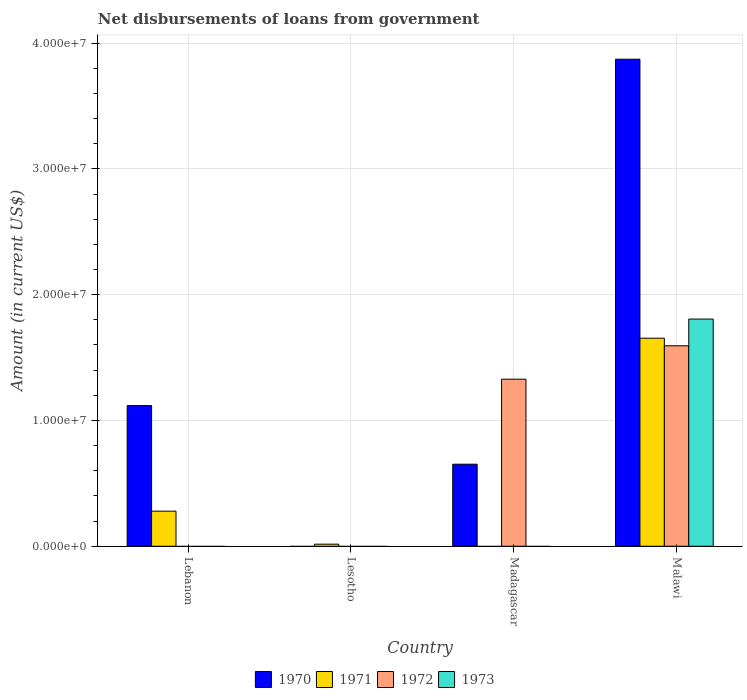How many different coloured bars are there?
Provide a succinct answer. 4. Are the number of bars per tick equal to the number of legend labels?
Keep it short and to the point. No. Are the number of bars on each tick of the X-axis equal?
Your answer should be very brief. No. How many bars are there on the 4th tick from the left?
Your answer should be very brief. 4. How many bars are there on the 2nd tick from the right?
Keep it short and to the point. 2. What is the label of the 1st group of bars from the left?
Provide a short and direct response. Lebanon. What is the amount of loan disbursed from government in 1971 in Lesotho?
Offer a terse response. 1.65e+05. Across all countries, what is the maximum amount of loan disbursed from government in 1972?
Make the answer very short. 1.59e+07. In which country was the amount of loan disbursed from government in 1972 maximum?
Give a very brief answer. Malawi. What is the total amount of loan disbursed from government in 1970 in the graph?
Provide a short and direct response. 5.64e+07. What is the difference between the amount of loan disbursed from government in 1971 in Lebanon and that in Malawi?
Ensure brevity in your answer.  -1.37e+07. What is the difference between the amount of loan disbursed from government in 1971 in Malawi and the amount of loan disbursed from government in 1973 in Lesotho?
Make the answer very short. 1.65e+07. What is the average amount of loan disbursed from government in 1971 per country?
Keep it short and to the point. 4.87e+06. Is the amount of loan disbursed from government in 1971 in Lebanon less than that in Lesotho?
Give a very brief answer. No. Is the difference between the amount of loan disbursed from government in 1970 in Madagascar and Malawi greater than the difference between the amount of loan disbursed from government in 1972 in Madagascar and Malawi?
Ensure brevity in your answer.  No. What is the difference between the highest and the second highest amount of loan disbursed from government in 1970?
Offer a very short reply. 3.22e+07. What is the difference between the highest and the lowest amount of loan disbursed from government in 1973?
Your answer should be very brief. 1.81e+07. Is the sum of the amount of loan disbursed from government in 1970 in Lebanon and Malawi greater than the maximum amount of loan disbursed from government in 1971 across all countries?
Your answer should be very brief. Yes. How many countries are there in the graph?
Your response must be concise. 4. Are the values on the major ticks of Y-axis written in scientific E-notation?
Keep it short and to the point. Yes. Does the graph contain any zero values?
Offer a terse response. Yes. Does the graph contain grids?
Ensure brevity in your answer.  Yes. What is the title of the graph?
Keep it short and to the point. Net disbursements of loans from government. What is the label or title of the Y-axis?
Keep it short and to the point. Amount (in current US$). What is the Amount (in current US$) of 1970 in Lebanon?
Provide a short and direct response. 1.12e+07. What is the Amount (in current US$) of 1971 in Lebanon?
Your response must be concise. 2.79e+06. What is the Amount (in current US$) in 1972 in Lebanon?
Provide a succinct answer. 0. What is the Amount (in current US$) in 1970 in Lesotho?
Your answer should be compact. 0. What is the Amount (in current US$) of 1971 in Lesotho?
Keep it short and to the point. 1.65e+05. What is the Amount (in current US$) of 1972 in Lesotho?
Your answer should be very brief. 0. What is the Amount (in current US$) of 1973 in Lesotho?
Make the answer very short. 0. What is the Amount (in current US$) of 1970 in Madagascar?
Give a very brief answer. 6.52e+06. What is the Amount (in current US$) of 1972 in Madagascar?
Your answer should be very brief. 1.33e+07. What is the Amount (in current US$) in 1970 in Malawi?
Give a very brief answer. 3.87e+07. What is the Amount (in current US$) in 1971 in Malawi?
Offer a terse response. 1.65e+07. What is the Amount (in current US$) of 1972 in Malawi?
Give a very brief answer. 1.59e+07. What is the Amount (in current US$) of 1973 in Malawi?
Your response must be concise. 1.81e+07. Across all countries, what is the maximum Amount (in current US$) in 1970?
Offer a terse response. 3.87e+07. Across all countries, what is the maximum Amount (in current US$) of 1971?
Give a very brief answer. 1.65e+07. Across all countries, what is the maximum Amount (in current US$) in 1972?
Give a very brief answer. 1.59e+07. Across all countries, what is the maximum Amount (in current US$) of 1973?
Offer a terse response. 1.81e+07. Across all countries, what is the minimum Amount (in current US$) in 1970?
Your answer should be compact. 0. What is the total Amount (in current US$) of 1970 in the graph?
Keep it short and to the point. 5.64e+07. What is the total Amount (in current US$) in 1971 in the graph?
Ensure brevity in your answer.  1.95e+07. What is the total Amount (in current US$) in 1972 in the graph?
Provide a succinct answer. 2.92e+07. What is the total Amount (in current US$) in 1973 in the graph?
Make the answer very short. 1.81e+07. What is the difference between the Amount (in current US$) in 1971 in Lebanon and that in Lesotho?
Offer a terse response. 2.62e+06. What is the difference between the Amount (in current US$) in 1970 in Lebanon and that in Madagascar?
Your response must be concise. 4.66e+06. What is the difference between the Amount (in current US$) in 1970 in Lebanon and that in Malawi?
Provide a short and direct response. -2.75e+07. What is the difference between the Amount (in current US$) in 1971 in Lebanon and that in Malawi?
Provide a succinct answer. -1.37e+07. What is the difference between the Amount (in current US$) in 1971 in Lesotho and that in Malawi?
Offer a very short reply. -1.64e+07. What is the difference between the Amount (in current US$) in 1970 in Madagascar and that in Malawi?
Offer a very short reply. -3.22e+07. What is the difference between the Amount (in current US$) in 1972 in Madagascar and that in Malawi?
Your answer should be compact. -2.65e+06. What is the difference between the Amount (in current US$) of 1970 in Lebanon and the Amount (in current US$) of 1971 in Lesotho?
Provide a succinct answer. 1.10e+07. What is the difference between the Amount (in current US$) of 1970 in Lebanon and the Amount (in current US$) of 1972 in Madagascar?
Your answer should be very brief. -2.10e+06. What is the difference between the Amount (in current US$) of 1971 in Lebanon and the Amount (in current US$) of 1972 in Madagascar?
Keep it short and to the point. -1.05e+07. What is the difference between the Amount (in current US$) of 1970 in Lebanon and the Amount (in current US$) of 1971 in Malawi?
Keep it short and to the point. -5.36e+06. What is the difference between the Amount (in current US$) in 1970 in Lebanon and the Amount (in current US$) in 1972 in Malawi?
Give a very brief answer. -4.76e+06. What is the difference between the Amount (in current US$) of 1970 in Lebanon and the Amount (in current US$) of 1973 in Malawi?
Provide a succinct answer. -6.88e+06. What is the difference between the Amount (in current US$) of 1971 in Lebanon and the Amount (in current US$) of 1972 in Malawi?
Give a very brief answer. -1.31e+07. What is the difference between the Amount (in current US$) in 1971 in Lebanon and the Amount (in current US$) in 1973 in Malawi?
Keep it short and to the point. -1.53e+07. What is the difference between the Amount (in current US$) of 1971 in Lesotho and the Amount (in current US$) of 1972 in Madagascar?
Your answer should be very brief. -1.31e+07. What is the difference between the Amount (in current US$) in 1971 in Lesotho and the Amount (in current US$) in 1972 in Malawi?
Provide a short and direct response. -1.58e+07. What is the difference between the Amount (in current US$) in 1971 in Lesotho and the Amount (in current US$) in 1973 in Malawi?
Your response must be concise. -1.79e+07. What is the difference between the Amount (in current US$) in 1970 in Madagascar and the Amount (in current US$) in 1971 in Malawi?
Keep it short and to the point. -1.00e+07. What is the difference between the Amount (in current US$) in 1970 in Madagascar and the Amount (in current US$) in 1972 in Malawi?
Give a very brief answer. -9.41e+06. What is the difference between the Amount (in current US$) of 1970 in Madagascar and the Amount (in current US$) of 1973 in Malawi?
Provide a succinct answer. -1.15e+07. What is the difference between the Amount (in current US$) in 1972 in Madagascar and the Amount (in current US$) in 1973 in Malawi?
Make the answer very short. -4.78e+06. What is the average Amount (in current US$) in 1970 per country?
Give a very brief answer. 1.41e+07. What is the average Amount (in current US$) in 1971 per country?
Keep it short and to the point. 4.87e+06. What is the average Amount (in current US$) of 1972 per country?
Ensure brevity in your answer.  7.30e+06. What is the average Amount (in current US$) in 1973 per country?
Provide a short and direct response. 4.52e+06. What is the difference between the Amount (in current US$) in 1970 and Amount (in current US$) in 1971 in Lebanon?
Give a very brief answer. 8.39e+06. What is the difference between the Amount (in current US$) of 1970 and Amount (in current US$) of 1972 in Madagascar?
Make the answer very short. -6.76e+06. What is the difference between the Amount (in current US$) in 1970 and Amount (in current US$) in 1971 in Malawi?
Ensure brevity in your answer.  2.22e+07. What is the difference between the Amount (in current US$) in 1970 and Amount (in current US$) in 1972 in Malawi?
Your response must be concise. 2.28e+07. What is the difference between the Amount (in current US$) of 1970 and Amount (in current US$) of 1973 in Malawi?
Make the answer very short. 2.07e+07. What is the difference between the Amount (in current US$) of 1971 and Amount (in current US$) of 1972 in Malawi?
Your answer should be very brief. 6.02e+05. What is the difference between the Amount (in current US$) of 1971 and Amount (in current US$) of 1973 in Malawi?
Your answer should be compact. -1.52e+06. What is the difference between the Amount (in current US$) of 1972 and Amount (in current US$) of 1973 in Malawi?
Make the answer very short. -2.12e+06. What is the ratio of the Amount (in current US$) in 1971 in Lebanon to that in Lesotho?
Make the answer very short. 16.9. What is the ratio of the Amount (in current US$) of 1970 in Lebanon to that in Madagascar?
Give a very brief answer. 1.71. What is the ratio of the Amount (in current US$) of 1970 in Lebanon to that in Malawi?
Provide a short and direct response. 0.29. What is the ratio of the Amount (in current US$) of 1971 in Lebanon to that in Malawi?
Keep it short and to the point. 0.17. What is the ratio of the Amount (in current US$) in 1970 in Madagascar to that in Malawi?
Offer a terse response. 0.17. What is the ratio of the Amount (in current US$) of 1972 in Madagascar to that in Malawi?
Keep it short and to the point. 0.83. What is the difference between the highest and the second highest Amount (in current US$) of 1970?
Offer a very short reply. 2.75e+07. What is the difference between the highest and the second highest Amount (in current US$) in 1971?
Give a very brief answer. 1.37e+07. What is the difference between the highest and the lowest Amount (in current US$) in 1970?
Ensure brevity in your answer.  3.87e+07. What is the difference between the highest and the lowest Amount (in current US$) in 1971?
Provide a short and direct response. 1.65e+07. What is the difference between the highest and the lowest Amount (in current US$) in 1972?
Ensure brevity in your answer.  1.59e+07. What is the difference between the highest and the lowest Amount (in current US$) in 1973?
Your answer should be very brief. 1.81e+07. 